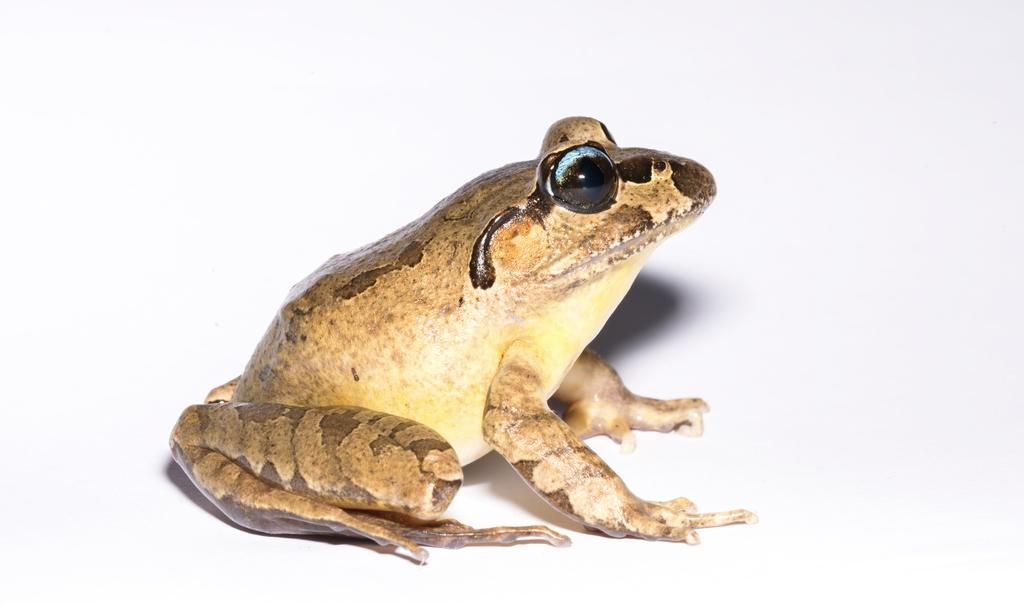What animal is present in the image? There is a frog in the image. What color is the background of the image? The background of the image is white. Can you hear the frog laughing in the image? There is no sound in the image, so it is not possible to hear the frog laughing. 